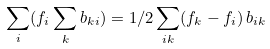Convert formula to latex. <formula><loc_0><loc_0><loc_500><loc_500>\sum _ { i } ( f _ { i } \sum _ { k } b _ { k i } ) = 1 / 2 \sum _ { i k } ( f _ { k } - f _ { i } ) \, b _ { i k }</formula> 